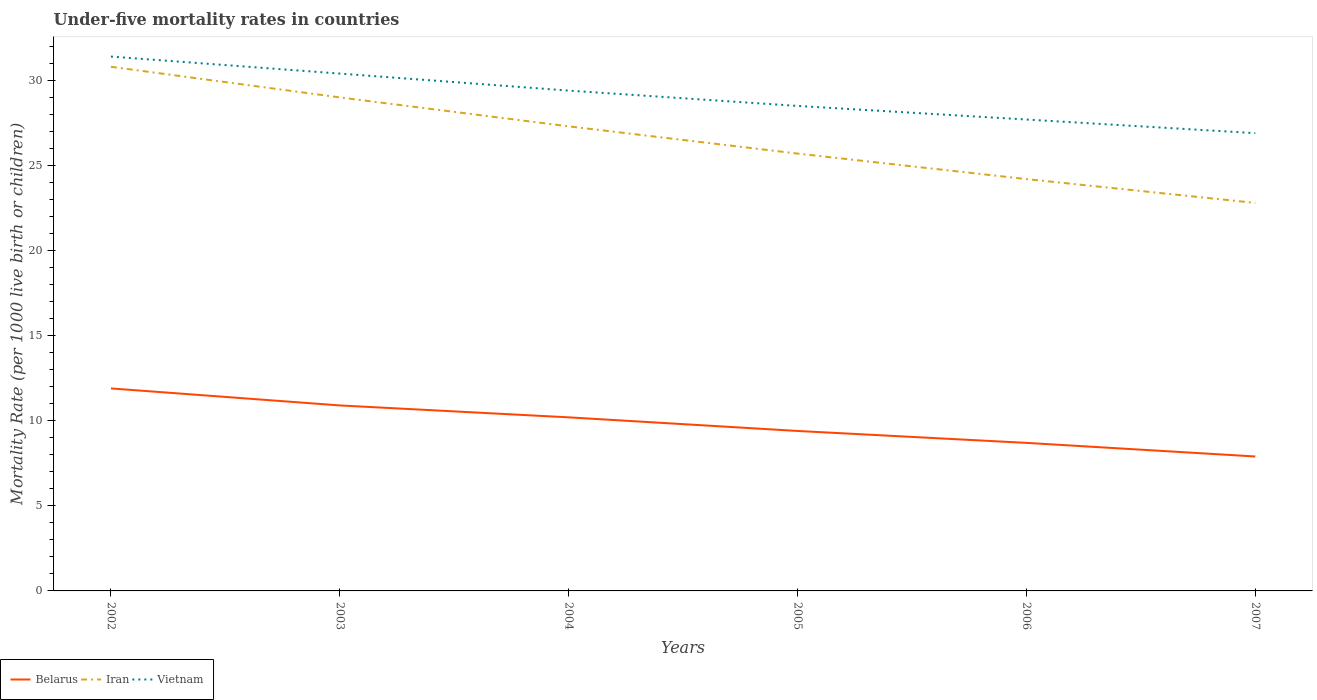How many different coloured lines are there?
Your response must be concise. 3. Is the number of lines equal to the number of legend labels?
Give a very brief answer. Yes. Across all years, what is the maximum under-five mortality rate in Vietnam?
Make the answer very short. 26.9. What is the difference between the highest and the lowest under-five mortality rate in Iran?
Give a very brief answer. 3. How many years are there in the graph?
Your answer should be compact. 6. What is the difference between two consecutive major ticks on the Y-axis?
Ensure brevity in your answer.  5. Are the values on the major ticks of Y-axis written in scientific E-notation?
Your answer should be very brief. No. Does the graph contain any zero values?
Give a very brief answer. No. Does the graph contain grids?
Give a very brief answer. No. How many legend labels are there?
Your answer should be compact. 3. How are the legend labels stacked?
Offer a terse response. Horizontal. What is the title of the graph?
Keep it short and to the point. Under-five mortality rates in countries. What is the label or title of the Y-axis?
Provide a short and direct response. Mortality Rate (per 1000 live birth or children). What is the Mortality Rate (per 1000 live birth or children) in Belarus in 2002?
Your answer should be very brief. 11.9. What is the Mortality Rate (per 1000 live birth or children) in Iran in 2002?
Your response must be concise. 30.8. What is the Mortality Rate (per 1000 live birth or children) of Vietnam in 2002?
Give a very brief answer. 31.4. What is the Mortality Rate (per 1000 live birth or children) of Belarus in 2003?
Give a very brief answer. 10.9. What is the Mortality Rate (per 1000 live birth or children) of Vietnam in 2003?
Your response must be concise. 30.4. What is the Mortality Rate (per 1000 live birth or children) in Iran in 2004?
Your answer should be compact. 27.3. What is the Mortality Rate (per 1000 live birth or children) of Vietnam in 2004?
Make the answer very short. 29.4. What is the Mortality Rate (per 1000 live birth or children) of Belarus in 2005?
Keep it short and to the point. 9.4. What is the Mortality Rate (per 1000 live birth or children) of Iran in 2005?
Your response must be concise. 25.7. What is the Mortality Rate (per 1000 live birth or children) of Iran in 2006?
Keep it short and to the point. 24.2. What is the Mortality Rate (per 1000 live birth or children) of Vietnam in 2006?
Provide a short and direct response. 27.7. What is the Mortality Rate (per 1000 live birth or children) of Iran in 2007?
Your response must be concise. 22.8. What is the Mortality Rate (per 1000 live birth or children) of Vietnam in 2007?
Make the answer very short. 26.9. Across all years, what is the maximum Mortality Rate (per 1000 live birth or children) of Iran?
Make the answer very short. 30.8. Across all years, what is the maximum Mortality Rate (per 1000 live birth or children) of Vietnam?
Your answer should be very brief. 31.4. Across all years, what is the minimum Mortality Rate (per 1000 live birth or children) of Iran?
Give a very brief answer. 22.8. Across all years, what is the minimum Mortality Rate (per 1000 live birth or children) of Vietnam?
Offer a terse response. 26.9. What is the total Mortality Rate (per 1000 live birth or children) in Belarus in the graph?
Keep it short and to the point. 59. What is the total Mortality Rate (per 1000 live birth or children) of Iran in the graph?
Offer a very short reply. 159.8. What is the total Mortality Rate (per 1000 live birth or children) of Vietnam in the graph?
Offer a very short reply. 174.3. What is the difference between the Mortality Rate (per 1000 live birth or children) in Belarus in 2002 and that in 2003?
Provide a short and direct response. 1. What is the difference between the Mortality Rate (per 1000 live birth or children) of Iran in 2002 and that in 2003?
Give a very brief answer. 1.8. What is the difference between the Mortality Rate (per 1000 live birth or children) in Belarus in 2002 and that in 2004?
Make the answer very short. 1.7. What is the difference between the Mortality Rate (per 1000 live birth or children) of Vietnam in 2002 and that in 2004?
Your answer should be compact. 2. What is the difference between the Mortality Rate (per 1000 live birth or children) in Iran in 2002 and that in 2005?
Keep it short and to the point. 5.1. What is the difference between the Mortality Rate (per 1000 live birth or children) in Vietnam in 2002 and that in 2005?
Ensure brevity in your answer.  2.9. What is the difference between the Mortality Rate (per 1000 live birth or children) in Belarus in 2002 and that in 2006?
Offer a very short reply. 3.2. What is the difference between the Mortality Rate (per 1000 live birth or children) in Vietnam in 2002 and that in 2006?
Your answer should be compact. 3.7. What is the difference between the Mortality Rate (per 1000 live birth or children) of Belarus in 2002 and that in 2007?
Your answer should be compact. 4. What is the difference between the Mortality Rate (per 1000 live birth or children) in Vietnam in 2002 and that in 2007?
Ensure brevity in your answer.  4.5. What is the difference between the Mortality Rate (per 1000 live birth or children) in Belarus in 2003 and that in 2004?
Keep it short and to the point. 0.7. What is the difference between the Mortality Rate (per 1000 live birth or children) in Vietnam in 2003 and that in 2005?
Offer a terse response. 1.9. What is the difference between the Mortality Rate (per 1000 live birth or children) in Vietnam in 2003 and that in 2006?
Offer a very short reply. 2.7. What is the difference between the Mortality Rate (per 1000 live birth or children) in Vietnam in 2004 and that in 2005?
Offer a terse response. 0.9. What is the difference between the Mortality Rate (per 1000 live birth or children) of Iran in 2004 and that in 2006?
Make the answer very short. 3.1. What is the difference between the Mortality Rate (per 1000 live birth or children) in Vietnam in 2004 and that in 2006?
Ensure brevity in your answer.  1.7. What is the difference between the Mortality Rate (per 1000 live birth or children) of Vietnam in 2004 and that in 2007?
Provide a succinct answer. 2.5. What is the difference between the Mortality Rate (per 1000 live birth or children) in Vietnam in 2005 and that in 2006?
Provide a short and direct response. 0.8. What is the difference between the Mortality Rate (per 1000 live birth or children) of Belarus in 2005 and that in 2007?
Offer a terse response. 1.5. What is the difference between the Mortality Rate (per 1000 live birth or children) in Vietnam in 2005 and that in 2007?
Your response must be concise. 1.6. What is the difference between the Mortality Rate (per 1000 live birth or children) in Belarus in 2006 and that in 2007?
Give a very brief answer. 0.8. What is the difference between the Mortality Rate (per 1000 live birth or children) in Vietnam in 2006 and that in 2007?
Your answer should be very brief. 0.8. What is the difference between the Mortality Rate (per 1000 live birth or children) of Belarus in 2002 and the Mortality Rate (per 1000 live birth or children) of Iran in 2003?
Offer a terse response. -17.1. What is the difference between the Mortality Rate (per 1000 live birth or children) of Belarus in 2002 and the Mortality Rate (per 1000 live birth or children) of Vietnam in 2003?
Ensure brevity in your answer.  -18.5. What is the difference between the Mortality Rate (per 1000 live birth or children) of Iran in 2002 and the Mortality Rate (per 1000 live birth or children) of Vietnam in 2003?
Your answer should be compact. 0.4. What is the difference between the Mortality Rate (per 1000 live birth or children) of Belarus in 2002 and the Mortality Rate (per 1000 live birth or children) of Iran in 2004?
Your response must be concise. -15.4. What is the difference between the Mortality Rate (per 1000 live birth or children) in Belarus in 2002 and the Mortality Rate (per 1000 live birth or children) in Vietnam in 2004?
Give a very brief answer. -17.5. What is the difference between the Mortality Rate (per 1000 live birth or children) of Iran in 2002 and the Mortality Rate (per 1000 live birth or children) of Vietnam in 2004?
Ensure brevity in your answer.  1.4. What is the difference between the Mortality Rate (per 1000 live birth or children) in Belarus in 2002 and the Mortality Rate (per 1000 live birth or children) in Iran in 2005?
Your answer should be compact. -13.8. What is the difference between the Mortality Rate (per 1000 live birth or children) of Belarus in 2002 and the Mortality Rate (per 1000 live birth or children) of Vietnam in 2005?
Keep it short and to the point. -16.6. What is the difference between the Mortality Rate (per 1000 live birth or children) of Iran in 2002 and the Mortality Rate (per 1000 live birth or children) of Vietnam in 2005?
Ensure brevity in your answer.  2.3. What is the difference between the Mortality Rate (per 1000 live birth or children) in Belarus in 2002 and the Mortality Rate (per 1000 live birth or children) in Iran in 2006?
Make the answer very short. -12.3. What is the difference between the Mortality Rate (per 1000 live birth or children) in Belarus in 2002 and the Mortality Rate (per 1000 live birth or children) in Vietnam in 2006?
Make the answer very short. -15.8. What is the difference between the Mortality Rate (per 1000 live birth or children) in Iran in 2002 and the Mortality Rate (per 1000 live birth or children) in Vietnam in 2006?
Provide a short and direct response. 3.1. What is the difference between the Mortality Rate (per 1000 live birth or children) of Belarus in 2003 and the Mortality Rate (per 1000 live birth or children) of Iran in 2004?
Provide a short and direct response. -16.4. What is the difference between the Mortality Rate (per 1000 live birth or children) of Belarus in 2003 and the Mortality Rate (per 1000 live birth or children) of Vietnam in 2004?
Offer a very short reply. -18.5. What is the difference between the Mortality Rate (per 1000 live birth or children) of Iran in 2003 and the Mortality Rate (per 1000 live birth or children) of Vietnam in 2004?
Ensure brevity in your answer.  -0.4. What is the difference between the Mortality Rate (per 1000 live birth or children) of Belarus in 2003 and the Mortality Rate (per 1000 live birth or children) of Iran in 2005?
Your answer should be compact. -14.8. What is the difference between the Mortality Rate (per 1000 live birth or children) in Belarus in 2003 and the Mortality Rate (per 1000 live birth or children) in Vietnam in 2005?
Ensure brevity in your answer.  -17.6. What is the difference between the Mortality Rate (per 1000 live birth or children) in Iran in 2003 and the Mortality Rate (per 1000 live birth or children) in Vietnam in 2005?
Provide a succinct answer. 0.5. What is the difference between the Mortality Rate (per 1000 live birth or children) of Belarus in 2003 and the Mortality Rate (per 1000 live birth or children) of Vietnam in 2006?
Keep it short and to the point. -16.8. What is the difference between the Mortality Rate (per 1000 live birth or children) of Iran in 2003 and the Mortality Rate (per 1000 live birth or children) of Vietnam in 2006?
Your answer should be very brief. 1.3. What is the difference between the Mortality Rate (per 1000 live birth or children) in Belarus in 2003 and the Mortality Rate (per 1000 live birth or children) in Iran in 2007?
Make the answer very short. -11.9. What is the difference between the Mortality Rate (per 1000 live birth or children) of Belarus in 2003 and the Mortality Rate (per 1000 live birth or children) of Vietnam in 2007?
Your answer should be very brief. -16. What is the difference between the Mortality Rate (per 1000 live birth or children) in Belarus in 2004 and the Mortality Rate (per 1000 live birth or children) in Iran in 2005?
Your answer should be compact. -15.5. What is the difference between the Mortality Rate (per 1000 live birth or children) of Belarus in 2004 and the Mortality Rate (per 1000 live birth or children) of Vietnam in 2005?
Ensure brevity in your answer.  -18.3. What is the difference between the Mortality Rate (per 1000 live birth or children) in Iran in 2004 and the Mortality Rate (per 1000 live birth or children) in Vietnam in 2005?
Make the answer very short. -1.2. What is the difference between the Mortality Rate (per 1000 live birth or children) of Belarus in 2004 and the Mortality Rate (per 1000 live birth or children) of Iran in 2006?
Give a very brief answer. -14. What is the difference between the Mortality Rate (per 1000 live birth or children) in Belarus in 2004 and the Mortality Rate (per 1000 live birth or children) in Vietnam in 2006?
Your answer should be compact. -17.5. What is the difference between the Mortality Rate (per 1000 live birth or children) in Belarus in 2004 and the Mortality Rate (per 1000 live birth or children) in Iran in 2007?
Ensure brevity in your answer.  -12.6. What is the difference between the Mortality Rate (per 1000 live birth or children) of Belarus in 2004 and the Mortality Rate (per 1000 live birth or children) of Vietnam in 2007?
Keep it short and to the point. -16.7. What is the difference between the Mortality Rate (per 1000 live birth or children) of Belarus in 2005 and the Mortality Rate (per 1000 live birth or children) of Iran in 2006?
Your answer should be very brief. -14.8. What is the difference between the Mortality Rate (per 1000 live birth or children) in Belarus in 2005 and the Mortality Rate (per 1000 live birth or children) in Vietnam in 2006?
Provide a succinct answer. -18.3. What is the difference between the Mortality Rate (per 1000 live birth or children) in Iran in 2005 and the Mortality Rate (per 1000 live birth or children) in Vietnam in 2006?
Offer a terse response. -2. What is the difference between the Mortality Rate (per 1000 live birth or children) of Belarus in 2005 and the Mortality Rate (per 1000 live birth or children) of Iran in 2007?
Your response must be concise. -13.4. What is the difference between the Mortality Rate (per 1000 live birth or children) of Belarus in 2005 and the Mortality Rate (per 1000 live birth or children) of Vietnam in 2007?
Your answer should be compact. -17.5. What is the difference between the Mortality Rate (per 1000 live birth or children) of Iran in 2005 and the Mortality Rate (per 1000 live birth or children) of Vietnam in 2007?
Keep it short and to the point. -1.2. What is the difference between the Mortality Rate (per 1000 live birth or children) in Belarus in 2006 and the Mortality Rate (per 1000 live birth or children) in Iran in 2007?
Make the answer very short. -14.1. What is the difference between the Mortality Rate (per 1000 live birth or children) in Belarus in 2006 and the Mortality Rate (per 1000 live birth or children) in Vietnam in 2007?
Provide a short and direct response. -18.2. What is the average Mortality Rate (per 1000 live birth or children) in Belarus per year?
Offer a terse response. 9.83. What is the average Mortality Rate (per 1000 live birth or children) in Iran per year?
Give a very brief answer. 26.63. What is the average Mortality Rate (per 1000 live birth or children) of Vietnam per year?
Ensure brevity in your answer.  29.05. In the year 2002, what is the difference between the Mortality Rate (per 1000 live birth or children) of Belarus and Mortality Rate (per 1000 live birth or children) of Iran?
Offer a terse response. -18.9. In the year 2002, what is the difference between the Mortality Rate (per 1000 live birth or children) in Belarus and Mortality Rate (per 1000 live birth or children) in Vietnam?
Offer a terse response. -19.5. In the year 2003, what is the difference between the Mortality Rate (per 1000 live birth or children) of Belarus and Mortality Rate (per 1000 live birth or children) of Iran?
Your response must be concise. -18.1. In the year 2003, what is the difference between the Mortality Rate (per 1000 live birth or children) of Belarus and Mortality Rate (per 1000 live birth or children) of Vietnam?
Your answer should be very brief. -19.5. In the year 2003, what is the difference between the Mortality Rate (per 1000 live birth or children) of Iran and Mortality Rate (per 1000 live birth or children) of Vietnam?
Make the answer very short. -1.4. In the year 2004, what is the difference between the Mortality Rate (per 1000 live birth or children) of Belarus and Mortality Rate (per 1000 live birth or children) of Iran?
Your answer should be compact. -17.1. In the year 2004, what is the difference between the Mortality Rate (per 1000 live birth or children) of Belarus and Mortality Rate (per 1000 live birth or children) of Vietnam?
Offer a terse response. -19.2. In the year 2004, what is the difference between the Mortality Rate (per 1000 live birth or children) of Iran and Mortality Rate (per 1000 live birth or children) of Vietnam?
Your answer should be very brief. -2.1. In the year 2005, what is the difference between the Mortality Rate (per 1000 live birth or children) of Belarus and Mortality Rate (per 1000 live birth or children) of Iran?
Ensure brevity in your answer.  -16.3. In the year 2005, what is the difference between the Mortality Rate (per 1000 live birth or children) in Belarus and Mortality Rate (per 1000 live birth or children) in Vietnam?
Ensure brevity in your answer.  -19.1. In the year 2006, what is the difference between the Mortality Rate (per 1000 live birth or children) of Belarus and Mortality Rate (per 1000 live birth or children) of Iran?
Offer a very short reply. -15.5. In the year 2007, what is the difference between the Mortality Rate (per 1000 live birth or children) in Belarus and Mortality Rate (per 1000 live birth or children) in Iran?
Your response must be concise. -14.9. In the year 2007, what is the difference between the Mortality Rate (per 1000 live birth or children) in Belarus and Mortality Rate (per 1000 live birth or children) in Vietnam?
Ensure brevity in your answer.  -19. In the year 2007, what is the difference between the Mortality Rate (per 1000 live birth or children) of Iran and Mortality Rate (per 1000 live birth or children) of Vietnam?
Keep it short and to the point. -4.1. What is the ratio of the Mortality Rate (per 1000 live birth or children) in Belarus in 2002 to that in 2003?
Your answer should be compact. 1.09. What is the ratio of the Mortality Rate (per 1000 live birth or children) of Iran in 2002 to that in 2003?
Ensure brevity in your answer.  1.06. What is the ratio of the Mortality Rate (per 1000 live birth or children) in Vietnam in 2002 to that in 2003?
Your answer should be compact. 1.03. What is the ratio of the Mortality Rate (per 1000 live birth or children) in Iran in 2002 to that in 2004?
Your answer should be very brief. 1.13. What is the ratio of the Mortality Rate (per 1000 live birth or children) of Vietnam in 2002 to that in 2004?
Make the answer very short. 1.07. What is the ratio of the Mortality Rate (per 1000 live birth or children) in Belarus in 2002 to that in 2005?
Offer a very short reply. 1.27. What is the ratio of the Mortality Rate (per 1000 live birth or children) in Iran in 2002 to that in 2005?
Offer a terse response. 1.2. What is the ratio of the Mortality Rate (per 1000 live birth or children) in Vietnam in 2002 to that in 2005?
Keep it short and to the point. 1.1. What is the ratio of the Mortality Rate (per 1000 live birth or children) of Belarus in 2002 to that in 2006?
Offer a terse response. 1.37. What is the ratio of the Mortality Rate (per 1000 live birth or children) in Iran in 2002 to that in 2006?
Provide a short and direct response. 1.27. What is the ratio of the Mortality Rate (per 1000 live birth or children) in Vietnam in 2002 to that in 2006?
Keep it short and to the point. 1.13. What is the ratio of the Mortality Rate (per 1000 live birth or children) in Belarus in 2002 to that in 2007?
Offer a terse response. 1.51. What is the ratio of the Mortality Rate (per 1000 live birth or children) in Iran in 2002 to that in 2007?
Provide a succinct answer. 1.35. What is the ratio of the Mortality Rate (per 1000 live birth or children) in Vietnam in 2002 to that in 2007?
Give a very brief answer. 1.17. What is the ratio of the Mortality Rate (per 1000 live birth or children) of Belarus in 2003 to that in 2004?
Make the answer very short. 1.07. What is the ratio of the Mortality Rate (per 1000 live birth or children) of Iran in 2003 to that in 2004?
Offer a terse response. 1.06. What is the ratio of the Mortality Rate (per 1000 live birth or children) of Vietnam in 2003 to that in 2004?
Your response must be concise. 1.03. What is the ratio of the Mortality Rate (per 1000 live birth or children) in Belarus in 2003 to that in 2005?
Your answer should be very brief. 1.16. What is the ratio of the Mortality Rate (per 1000 live birth or children) in Iran in 2003 to that in 2005?
Offer a very short reply. 1.13. What is the ratio of the Mortality Rate (per 1000 live birth or children) in Vietnam in 2003 to that in 2005?
Your answer should be very brief. 1.07. What is the ratio of the Mortality Rate (per 1000 live birth or children) of Belarus in 2003 to that in 2006?
Ensure brevity in your answer.  1.25. What is the ratio of the Mortality Rate (per 1000 live birth or children) of Iran in 2003 to that in 2006?
Make the answer very short. 1.2. What is the ratio of the Mortality Rate (per 1000 live birth or children) of Vietnam in 2003 to that in 2006?
Keep it short and to the point. 1.1. What is the ratio of the Mortality Rate (per 1000 live birth or children) of Belarus in 2003 to that in 2007?
Offer a very short reply. 1.38. What is the ratio of the Mortality Rate (per 1000 live birth or children) in Iran in 2003 to that in 2007?
Your answer should be compact. 1.27. What is the ratio of the Mortality Rate (per 1000 live birth or children) of Vietnam in 2003 to that in 2007?
Give a very brief answer. 1.13. What is the ratio of the Mortality Rate (per 1000 live birth or children) of Belarus in 2004 to that in 2005?
Keep it short and to the point. 1.09. What is the ratio of the Mortality Rate (per 1000 live birth or children) in Iran in 2004 to that in 2005?
Your answer should be compact. 1.06. What is the ratio of the Mortality Rate (per 1000 live birth or children) of Vietnam in 2004 to that in 2005?
Make the answer very short. 1.03. What is the ratio of the Mortality Rate (per 1000 live birth or children) of Belarus in 2004 to that in 2006?
Keep it short and to the point. 1.17. What is the ratio of the Mortality Rate (per 1000 live birth or children) of Iran in 2004 to that in 2006?
Make the answer very short. 1.13. What is the ratio of the Mortality Rate (per 1000 live birth or children) in Vietnam in 2004 to that in 2006?
Provide a succinct answer. 1.06. What is the ratio of the Mortality Rate (per 1000 live birth or children) of Belarus in 2004 to that in 2007?
Offer a terse response. 1.29. What is the ratio of the Mortality Rate (per 1000 live birth or children) of Iran in 2004 to that in 2007?
Provide a succinct answer. 1.2. What is the ratio of the Mortality Rate (per 1000 live birth or children) in Vietnam in 2004 to that in 2007?
Your answer should be very brief. 1.09. What is the ratio of the Mortality Rate (per 1000 live birth or children) of Belarus in 2005 to that in 2006?
Make the answer very short. 1.08. What is the ratio of the Mortality Rate (per 1000 live birth or children) of Iran in 2005 to that in 2006?
Provide a succinct answer. 1.06. What is the ratio of the Mortality Rate (per 1000 live birth or children) of Vietnam in 2005 to that in 2006?
Make the answer very short. 1.03. What is the ratio of the Mortality Rate (per 1000 live birth or children) in Belarus in 2005 to that in 2007?
Provide a short and direct response. 1.19. What is the ratio of the Mortality Rate (per 1000 live birth or children) in Iran in 2005 to that in 2007?
Ensure brevity in your answer.  1.13. What is the ratio of the Mortality Rate (per 1000 live birth or children) in Vietnam in 2005 to that in 2007?
Offer a very short reply. 1.06. What is the ratio of the Mortality Rate (per 1000 live birth or children) in Belarus in 2006 to that in 2007?
Provide a succinct answer. 1.1. What is the ratio of the Mortality Rate (per 1000 live birth or children) in Iran in 2006 to that in 2007?
Give a very brief answer. 1.06. What is the ratio of the Mortality Rate (per 1000 live birth or children) in Vietnam in 2006 to that in 2007?
Provide a short and direct response. 1.03. What is the difference between the highest and the second highest Mortality Rate (per 1000 live birth or children) in Iran?
Keep it short and to the point. 1.8. What is the difference between the highest and the second highest Mortality Rate (per 1000 live birth or children) in Vietnam?
Your response must be concise. 1. 